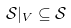<formula> <loc_0><loc_0><loc_500><loc_500>\mathcal { S } | _ { V } \subseteq \mathcal { S }</formula> 